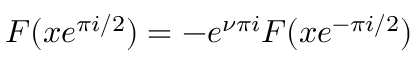<formula> <loc_0><loc_0><loc_500><loc_500>F ( x e ^ { \pi i / 2 } ) = - e ^ { \nu \pi i } F ( x e ^ { - \pi i / 2 } )</formula> 